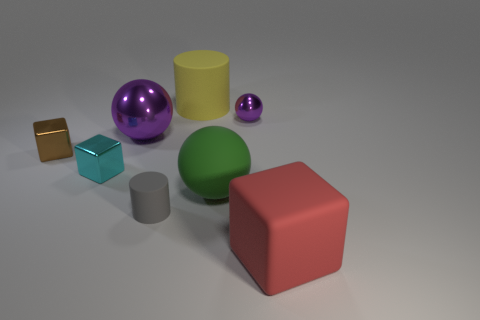Subtract all blue blocks. How many purple spheres are left? 2 Subtract all small spheres. How many spheres are left? 2 Add 1 shiny blocks. How many objects exist? 9 Subtract all cylinders. How many objects are left? 6 Subtract all yellow balls. Subtract all gray cubes. How many balls are left? 3 Add 3 tiny cylinders. How many tiny cylinders are left? 4 Add 5 green matte balls. How many green matte balls exist? 6 Subtract 0 gray blocks. How many objects are left? 8 Subtract all big yellow shiny spheres. Subtract all purple objects. How many objects are left? 6 